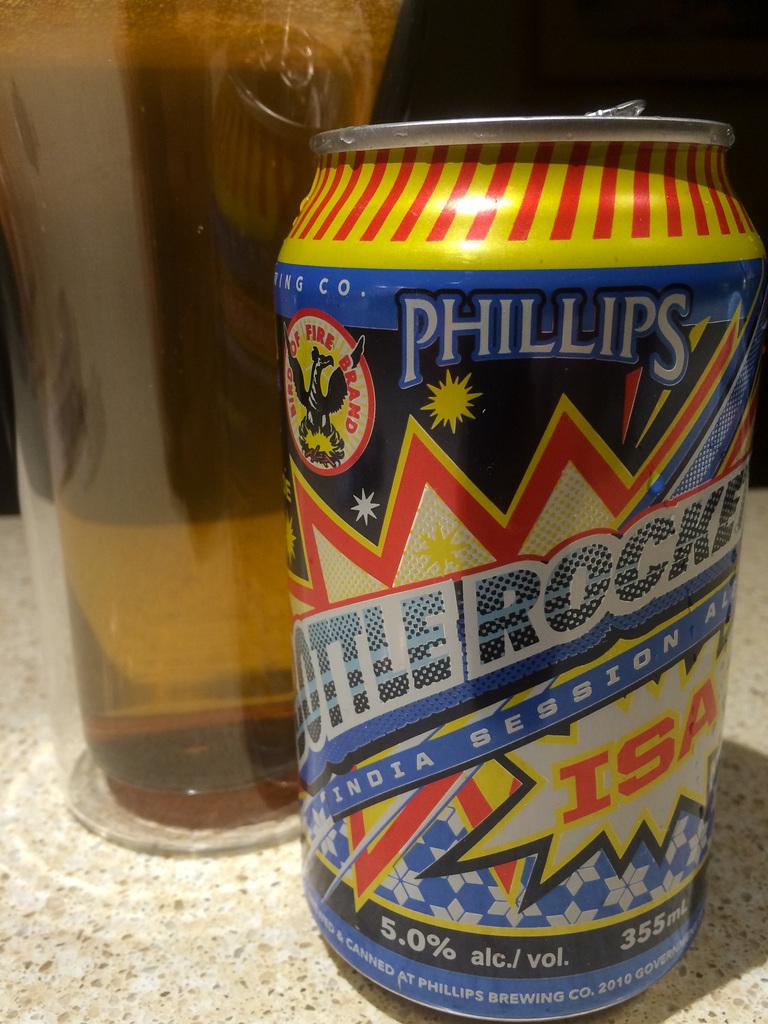<image>
Create a compact narrative representing the image presented. the letters ISA are on the soda can 